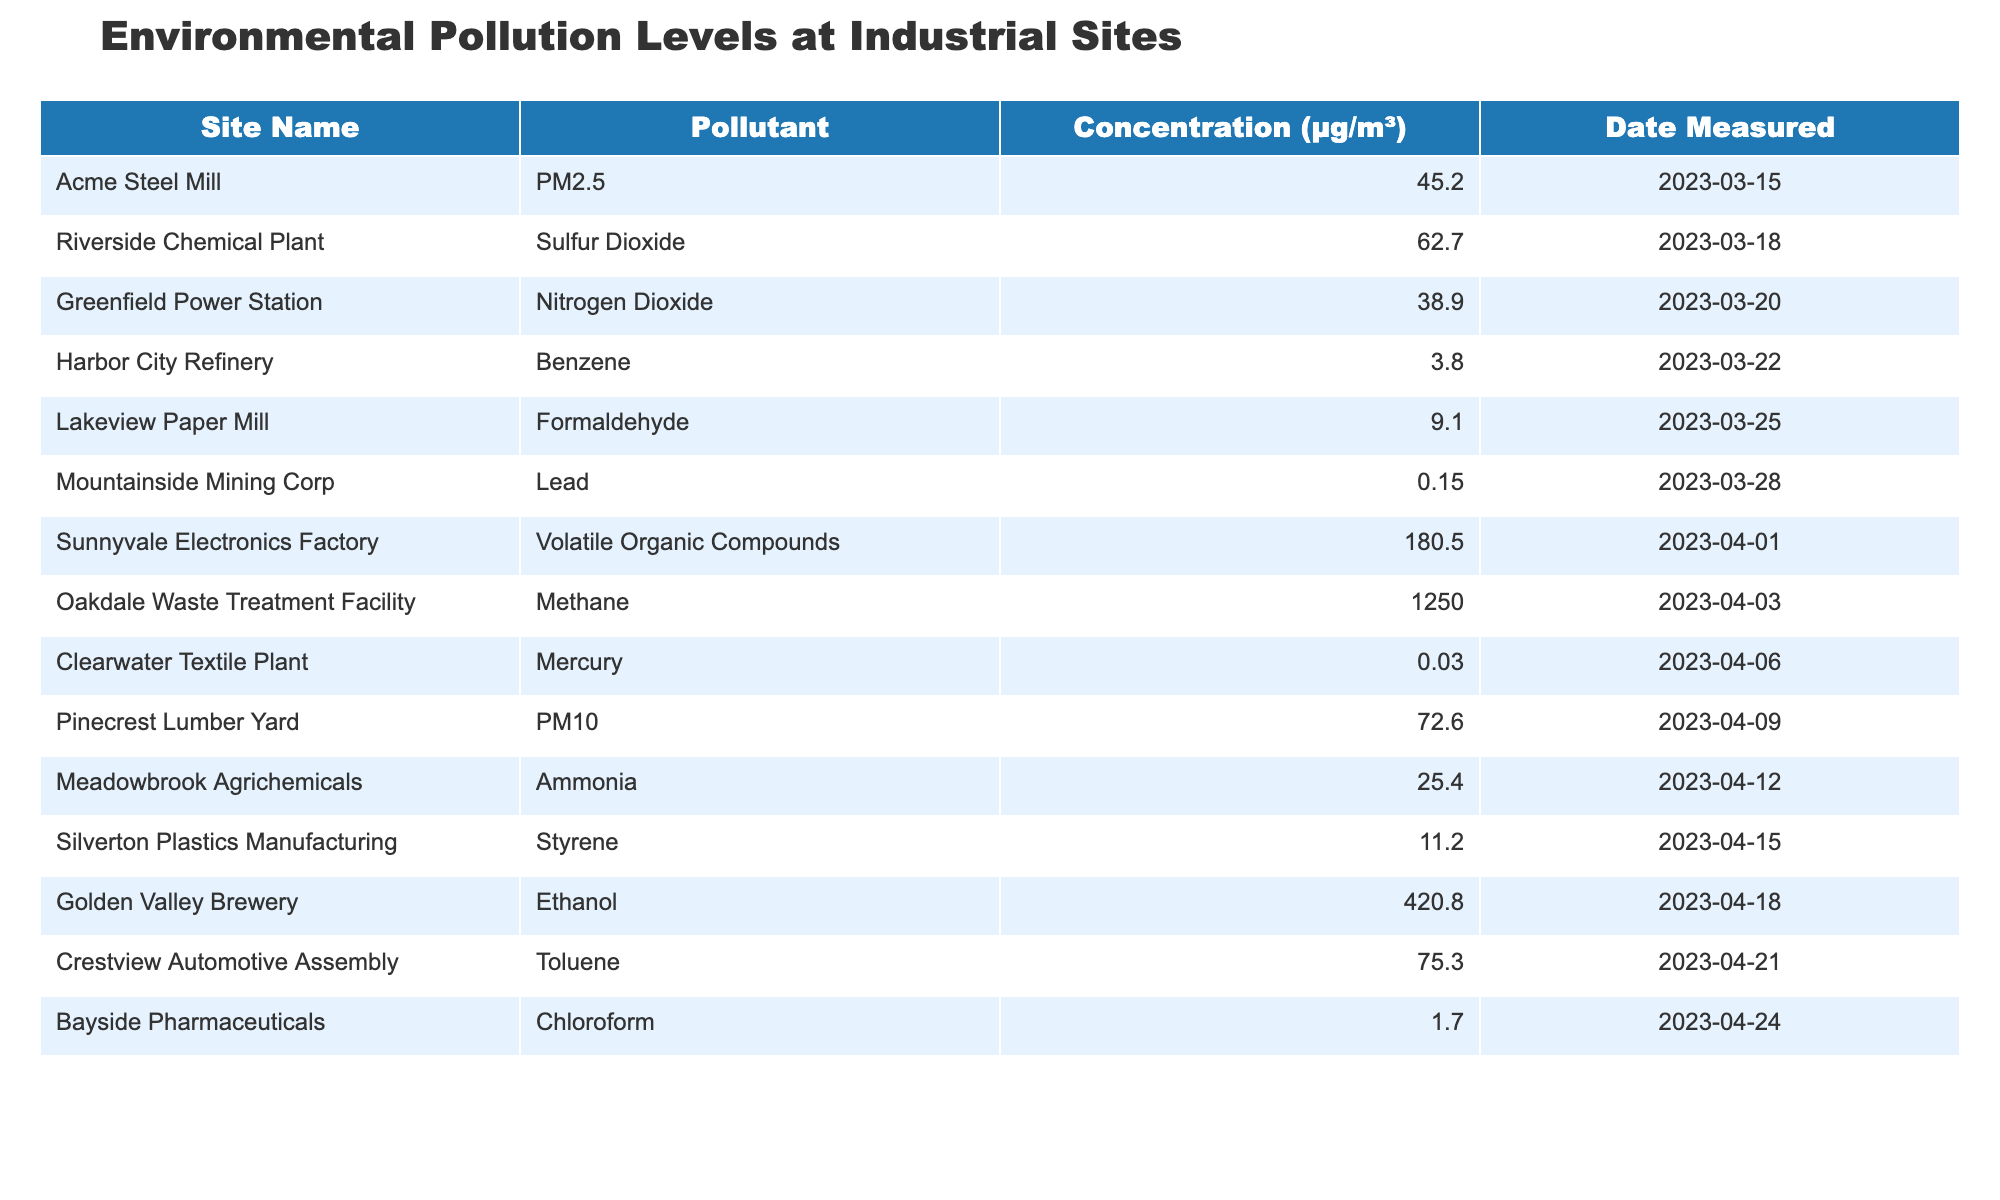What pollutant had the highest concentration at any site? The highest concentration in the table is 1250.0 μg/m³ for Methane at Oakdale Waste Treatment Facility.
Answer: Methane Which site measured PM2.5, and what was its concentration? The Acme Steel Mill measured PM2.5 with a concentration of 45.2 μg/m³.
Answer: 45.2 μg/m³ Is the concentration of Benzene at Harbor City Refinery above 3 μg/m³? The concentration of Benzene at Harbor City Refinery is 3.8 μg/m³, which is above 3 μg/m³.
Answer: Yes What is the average concentration of pollutants measured in μg/m³? The concentrations are 45.2, 62.7, 38.9, 3.8, 9.1, 0.15, 180.5, 1250.0, 0.03, 72.6, 25.4, 11.2, 420.8, 75.3, and 1.7. Summing these values gives 1750.9, and there are 14 data points, so the average is 1750.9/14 ≈ 125.8 μg/m³.
Answer: Approximately 125.8 μg/m³ Which two pollutants had concentrations below 1 μg/m³? There are no pollutants in this table with concentrations below 1 μg/m³. The lowest is Lead at 0.15 μg/m³ and Mercury at 0.03 μg/m³.
Answer: False What is the difference in concentration between the site with the highest and lowest measured values? The highest concentration is 1250.0 μg/m³ (Methane) and the lowest is 0.03 μg/m³ (Mercury). The difference is 1250.0 - 0.03 = 1249.97 μg/m³.
Answer: 1249.97 μg/m³ How many sites reported concentrations of Volatile Organic Compounds? Only one site, Sunnyvale Electronics Factory, reported a concentration of Volatile Organic Compounds at 180.5 μg/m³.
Answer: 1 Which site had the highest level of Ethanol and what was its value? Golden Valley Brewery had the highest concentration of Ethanol at 420.8 μg/m³.
Answer: 420.8 μg/m³ Was the concentration of Sulfur Dioxide at Riverside Chemical Plant greater than the combined concentrations of Benzene and Styrene? Sulfur Dioxide is at 62.7 μg/m³, while Benzene (3.8 μg/m³) + Styrene (11.2 μg/m³) sums to 15.0 μg/m³. Since 62.7 > 15.0, the answer is Yes.
Answer: Yes How many pollutants reported concentrations greater than 100 μg/m³? The pollutants with concentrations greater than 100 μg/m³ are Methane (1250.0), and Volatile Organic Compounds (180.5). Hence, there are 2 such pollutants.
Answer: 2 What is the total concentration of all nitrogen-related pollutants? Only Nitrogen Dioxide is included in this table, with a concentration of 38.9 μg/m³. Thus, the total for nitrogen-related pollutants is 38.9 μg/m³.
Answer: 38.9 μg/m³ 